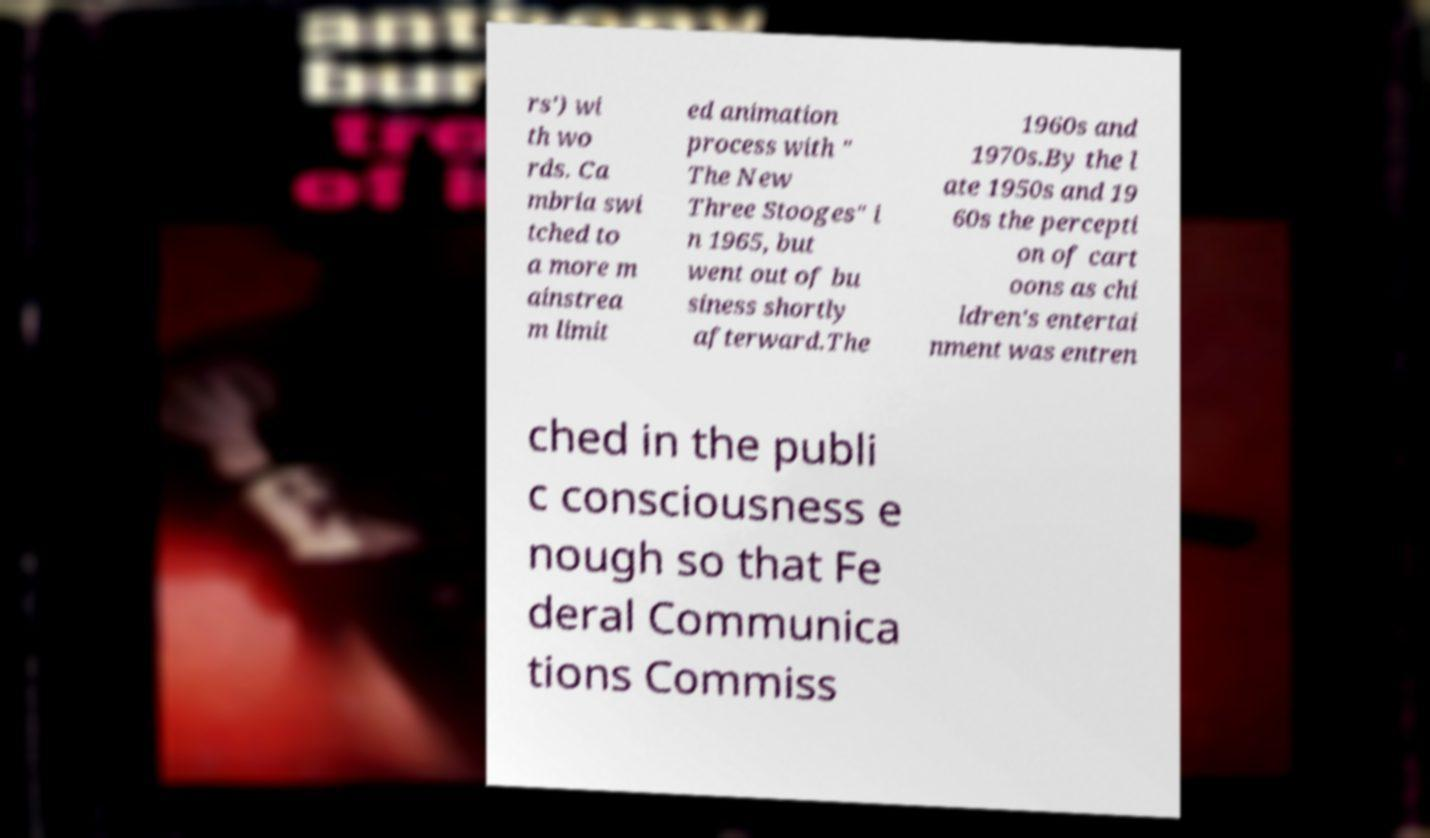Can you read and provide the text displayed in the image?This photo seems to have some interesting text. Can you extract and type it out for me? rs') wi th wo rds. Ca mbria swi tched to a more m ainstrea m limit ed animation process with " The New Three Stooges" i n 1965, but went out of bu siness shortly afterward.The 1960s and 1970s.By the l ate 1950s and 19 60s the percepti on of cart oons as chi ldren's entertai nment was entren ched in the publi c consciousness e nough so that Fe deral Communica tions Commiss 